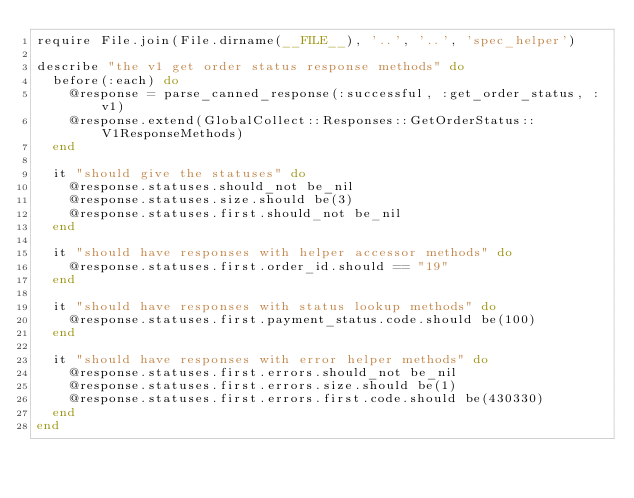Convert code to text. <code><loc_0><loc_0><loc_500><loc_500><_Ruby_>require File.join(File.dirname(__FILE__), '..', '..', 'spec_helper')

describe "the v1 get order status response methods" do
  before(:each) do
    @response = parse_canned_response(:successful, :get_order_status, :v1)
    @response.extend(GlobalCollect::Responses::GetOrderStatus::V1ResponseMethods)
  end

  it "should give the statuses" do
    @response.statuses.should_not be_nil
    @response.statuses.size.should be(3)
    @response.statuses.first.should_not be_nil
  end
  
  it "should have responses with helper accessor methods" do
    @response.statuses.first.order_id.should == "19"
  end
  
  it "should have responses with status lookup methods" do
    @response.statuses.first.payment_status.code.should be(100)
  end
  
  it "should have responses with error helper methods" do
    @response.statuses.first.errors.should_not be_nil
    @response.statuses.first.errors.size.should be(1)
    @response.statuses.first.errors.first.code.should be(430330)
  end
end</code> 